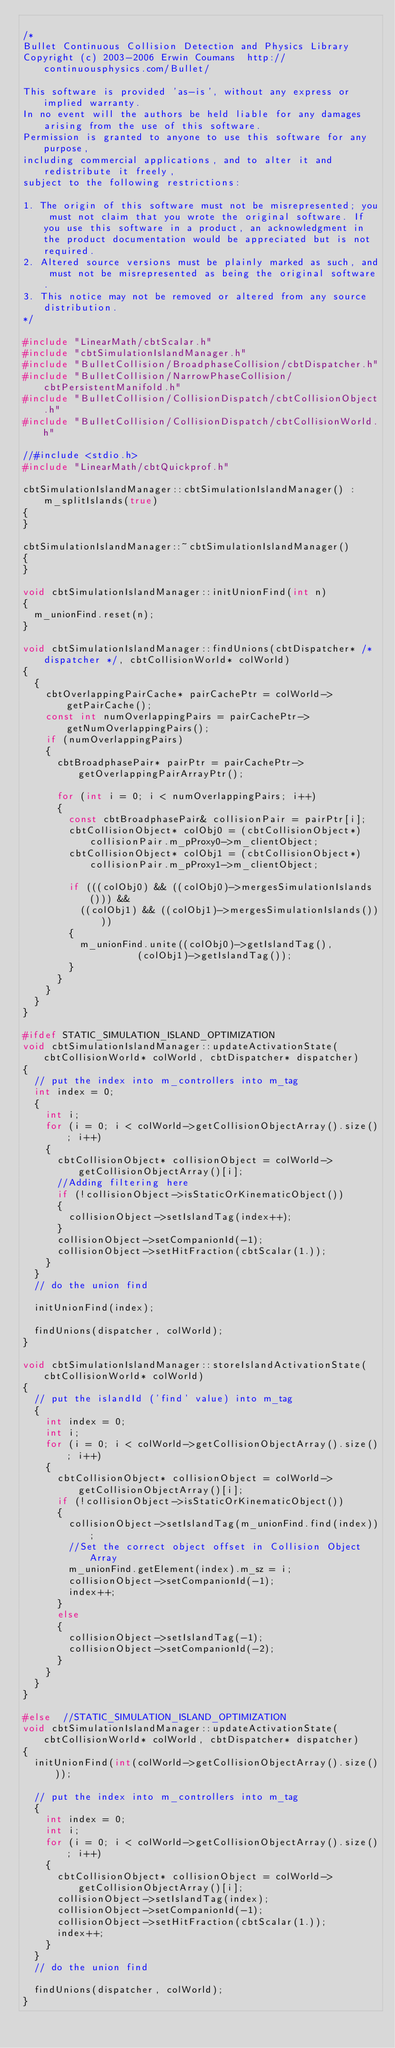<code> <loc_0><loc_0><loc_500><loc_500><_C++_>
/*
Bullet Continuous Collision Detection and Physics Library
Copyright (c) 2003-2006 Erwin Coumans  http://continuousphysics.com/Bullet/

This software is provided 'as-is', without any express or implied warranty.
In no event will the authors be held liable for any damages arising from the use of this software.
Permission is granted to anyone to use this software for any purpose, 
including commercial applications, and to alter it and redistribute it freely, 
subject to the following restrictions:

1. The origin of this software must not be misrepresented; you must not claim that you wrote the original software. If you use this software in a product, an acknowledgment in the product documentation would be appreciated but is not required.
2. Altered source versions must be plainly marked as such, and must not be misrepresented as being the original software.
3. This notice may not be removed or altered from any source distribution.
*/

#include "LinearMath/cbtScalar.h"
#include "cbtSimulationIslandManager.h"
#include "BulletCollision/BroadphaseCollision/cbtDispatcher.h"
#include "BulletCollision/NarrowPhaseCollision/cbtPersistentManifold.h"
#include "BulletCollision/CollisionDispatch/cbtCollisionObject.h"
#include "BulletCollision/CollisionDispatch/cbtCollisionWorld.h"

//#include <stdio.h>
#include "LinearMath/cbtQuickprof.h"

cbtSimulationIslandManager::cbtSimulationIslandManager() : m_splitIslands(true)
{
}

cbtSimulationIslandManager::~cbtSimulationIslandManager()
{
}

void cbtSimulationIslandManager::initUnionFind(int n)
{
	m_unionFind.reset(n);
}

void cbtSimulationIslandManager::findUnions(cbtDispatcher* /* dispatcher */, cbtCollisionWorld* colWorld)
{
	{
		cbtOverlappingPairCache* pairCachePtr = colWorld->getPairCache();
		const int numOverlappingPairs = pairCachePtr->getNumOverlappingPairs();
		if (numOverlappingPairs)
		{
			cbtBroadphasePair* pairPtr = pairCachePtr->getOverlappingPairArrayPtr();

			for (int i = 0; i < numOverlappingPairs; i++)
			{
				const cbtBroadphasePair& collisionPair = pairPtr[i];
				cbtCollisionObject* colObj0 = (cbtCollisionObject*)collisionPair.m_pProxy0->m_clientObject;
				cbtCollisionObject* colObj1 = (cbtCollisionObject*)collisionPair.m_pProxy1->m_clientObject;

				if (((colObj0) && ((colObj0)->mergesSimulationIslands())) &&
					((colObj1) && ((colObj1)->mergesSimulationIslands())))
				{
					m_unionFind.unite((colObj0)->getIslandTag(),
									  (colObj1)->getIslandTag());
				}
			}
		}
	}
}

#ifdef STATIC_SIMULATION_ISLAND_OPTIMIZATION
void cbtSimulationIslandManager::updateActivationState(cbtCollisionWorld* colWorld, cbtDispatcher* dispatcher)
{
	// put the index into m_controllers into m_tag
	int index = 0;
	{
		int i;
		for (i = 0; i < colWorld->getCollisionObjectArray().size(); i++)
		{
			cbtCollisionObject* collisionObject = colWorld->getCollisionObjectArray()[i];
			//Adding filtering here
			if (!collisionObject->isStaticOrKinematicObject())
			{
				collisionObject->setIslandTag(index++);
			}
			collisionObject->setCompanionId(-1);
			collisionObject->setHitFraction(cbtScalar(1.));
		}
	}
	// do the union find

	initUnionFind(index);

	findUnions(dispatcher, colWorld);
}

void cbtSimulationIslandManager::storeIslandActivationState(cbtCollisionWorld* colWorld)
{
	// put the islandId ('find' value) into m_tag
	{
		int index = 0;
		int i;
		for (i = 0; i < colWorld->getCollisionObjectArray().size(); i++)
		{
			cbtCollisionObject* collisionObject = colWorld->getCollisionObjectArray()[i];
			if (!collisionObject->isStaticOrKinematicObject())
			{
				collisionObject->setIslandTag(m_unionFind.find(index));
				//Set the correct object offset in Collision Object Array
				m_unionFind.getElement(index).m_sz = i;
				collisionObject->setCompanionId(-1);
				index++;
			}
			else
			{
				collisionObject->setIslandTag(-1);
				collisionObject->setCompanionId(-2);
			}
		}
	}
}

#else  //STATIC_SIMULATION_ISLAND_OPTIMIZATION
void cbtSimulationIslandManager::updateActivationState(cbtCollisionWorld* colWorld, cbtDispatcher* dispatcher)
{
	initUnionFind(int(colWorld->getCollisionObjectArray().size()));

	// put the index into m_controllers into m_tag
	{
		int index = 0;
		int i;
		for (i = 0; i < colWorld->getCollisionObjectArray().size(); i++)
		{
			cbtCollisionObject* collisionObject = colWorld->getCollisionObjectArray()[i];
			collisionObject->setIslandTag(index);
			collisionObject->setCompanionId(-1);
			collisionObject->setHitFraction(cbtScalar(1.));
			index++;
		}
	}
	// do the union find

	findUnions(dispatcher, colWorld);
}
</code> 